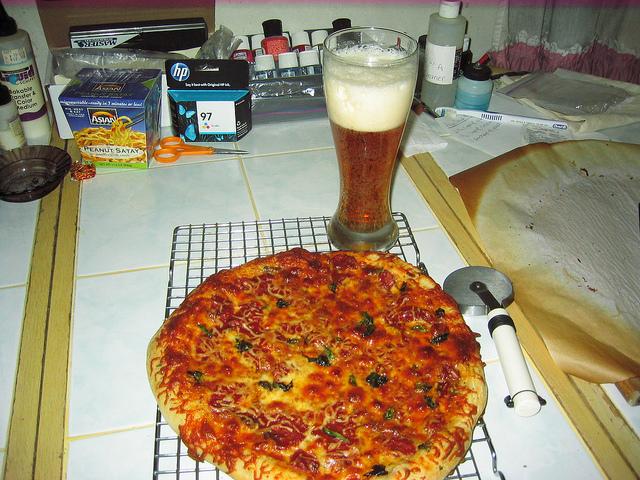What is beside the pizza?
Give a very brief answer. Beer. What is in the box marked 97?
Quick response, please. Printer ink. Is any of the pizza gone?
Be succinct. No. What is in the glass?
Keep it brief. Beer. 